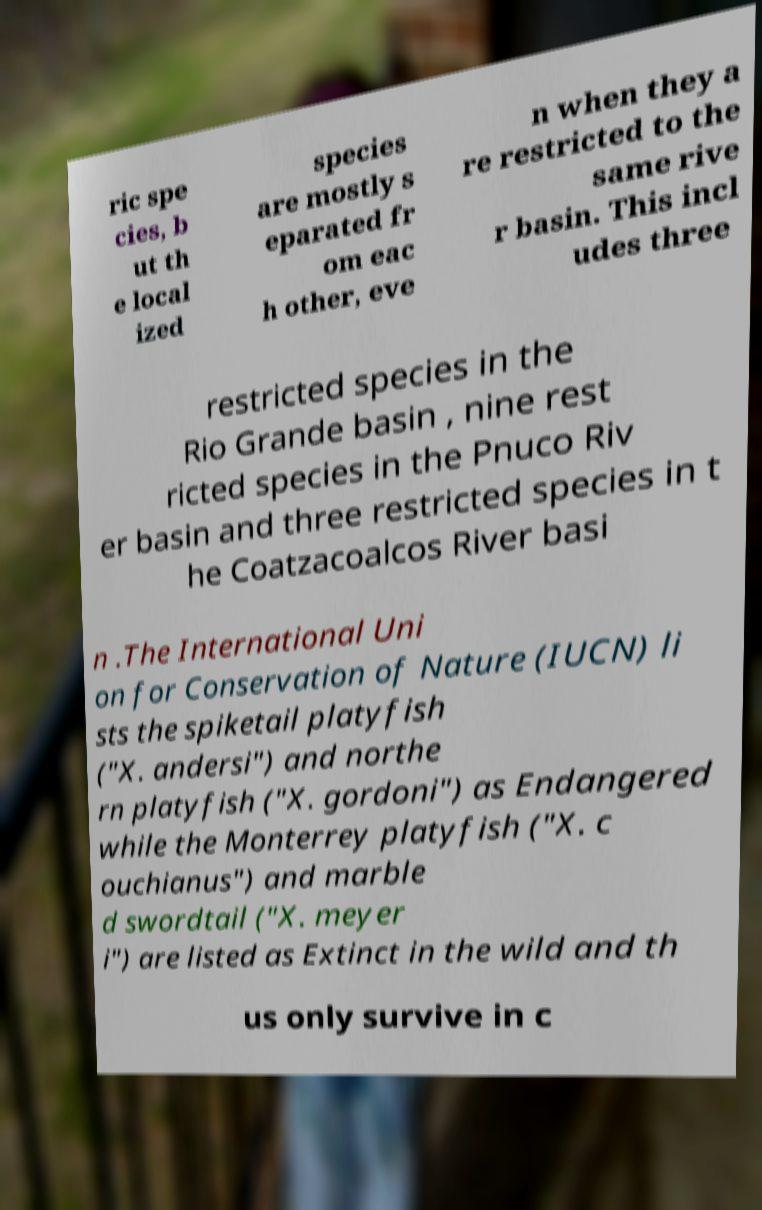Could you extract and type out the text from this image? ric spe cies, b ut th e local ized species are mostly s eparated fr om eac h other, eve n when they a re restricted to the same rive r basin. This incl udes three restricted species in the Rio Grande basin , nine rest ricted species in the Pnuco Riv er basin and three restricted species in t he Coatzacoalcos River basi n .The International Uni on for Conservation of Nature (IUCN) li sts the spiketail platyfish ("X. andersi") and northe rn platyfish ("X. gordoni") as Endangered while the Monterrey platyfish ("X. c ouchianus") and marble d swordtail ("X. meyer i") are listed as Extinct in the wild and th us only survive in c 